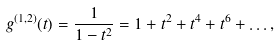Convert formula to latex. <formula><loc_0><loc_0><loc_500><loc_500>g ^ { ( 1 , 2 ) } ( t ) = \frac { 1 } { 1 - t ^ { 2 } } = 1 + t ^ { 2 } + t ^ { 4 } + t ^ { 6 } + \dots ,</formula> 